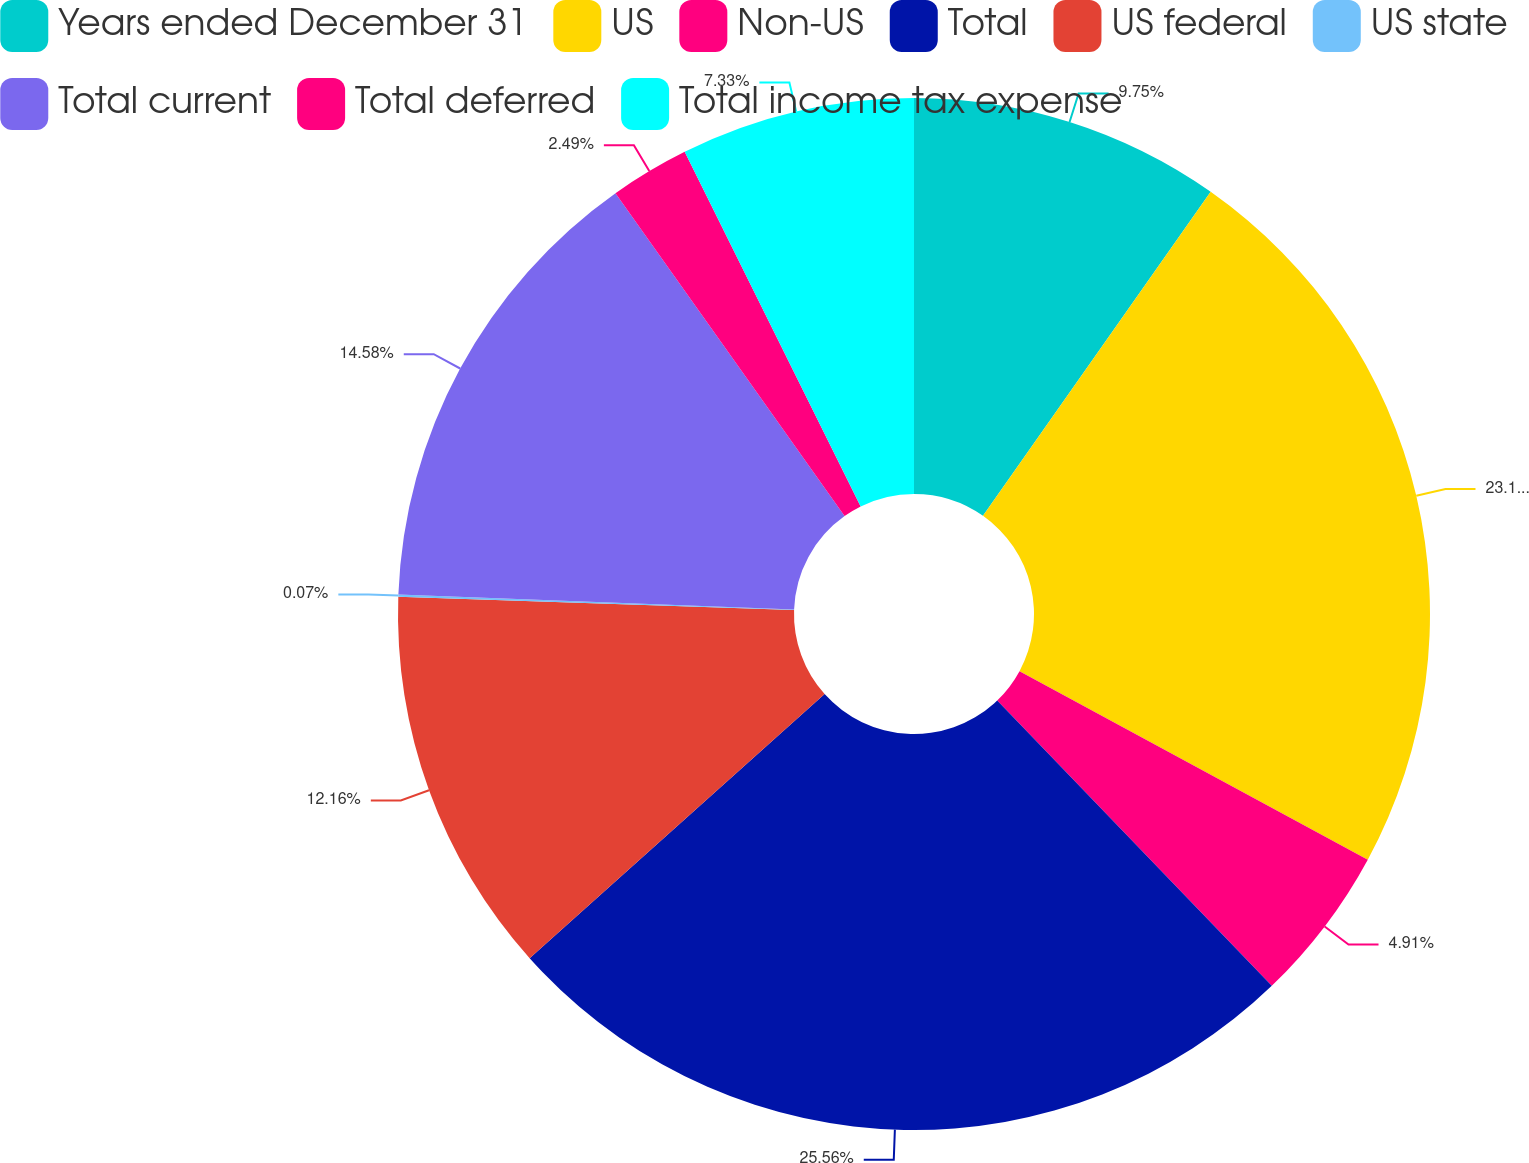<chart> <loc_0><loc_0><loc_500><loc_500><pie_chart><fcel>Years ended December 31<fcel>US<fcel>Non-US<fcel>Total<fcel>US federal<fcel>US state<fcel>Total current<fcel>Total deferred<fcel>Total income tax expense<nl><fcel>9.75%<fcel>23.15%<fcel>4.91%<fcel>25.57%<fcel>12.16%<fcel>0.07%<fcel>14.58%<fcel>2.49%<fcel>7.33%<nl></chart> 